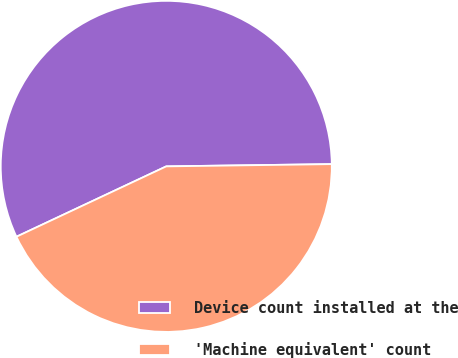<chart> <loc_0><loc_0><loc_500><loc_500><pie_chart><fcel>Device count installed at the<fcel>'Machine equivalent' count<nl><fcel>56.77%<fcel>43.23%<nl></chart> 